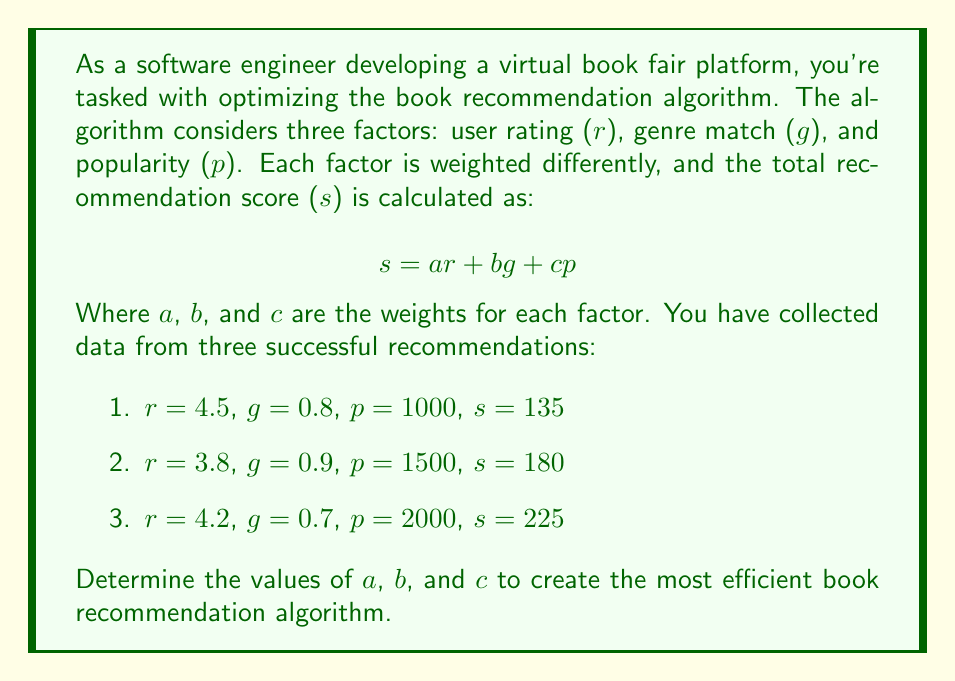Could you help me with this problem? To solve this problem, we need to set up a system of equations using the given data. Each recommendation provides us with an equation:

1. $4.5a + 0.8b + 1000c = 135$
2. $3.8a + 0.9b + 1500c = 180$
3. $4.2a + 0.7b + 2000c = 225$

Now we have a system of three equations with three unknowns. We can solve this using the elimination method:

Step 1: Multiply equation (1) by 2 and equation (2) by -1 to eliminate $b$:
$9a + 1.6b + 2000c = 270$
$-3.8a - 0.9b - 1500c = -180$
Adding these equations:
$5.2a + 0.7b + 500c = 90$ ... (4)

Step 2: Subtract equation (1) from equation (3) to eliminate $a$:
$-0.3a - 0.1b + 1000c = 90$ ... (5)

Step 3: Multiply equation (4) by 0.1 and equation (5) by 0.7:
$0.52a + 0.07b + 50c = 9$
$-0.21a - 0.07b + 700c = 63$
Adding these equations:
$0.31a + 750c = 72$ ... (6)

Step 4: Multiply equation (6) by 3.2258 to isolate $a$:
$a + 2419.35c = 232.26$ ... (7)

Step 5: Substitute this expression for $a$ into equation (1):
$4.5(232.26 - 2419.35c) + 0.8b + 1000c = 135$
$1045.17 - 10887.075c + 0.8b + 1000c = 135$
$0.8b - 9887.075c = -910.17$ ... (8)

Step 6: Solve equations (7) and (8) simultaneously:
From (7): $a = 232.26 - 2419.35c$
From (8): $b = (-910.17 + 9887.075c) / 0.8 = -1137.71 + 12358.84c$

Step 7: Substitute these expressions into equation (1):
$4.5(232.26 - 2419.35c) + 0.8(-1137.71 + 12358.84c) + 1000c = 135$
$1045.17 - 10887.075c - 910.168 + 9887.072c + 1000c = 135$
$135.002 - 0.003c = 135$
$-0.003c = -0.002$
$c = 0.667$

Step 8: Calculate $a$ and $b$ using the values found for $c$:
$a = 232.26 - 2419.35(0.667) = 232.26 - 1613.71 = 18.55$
$b = -1137.71 + 12358.84(0.667) = -1137.71 + 8243.35 = 7105.64$

Therefore, the values for $a$, $b$, and $c$ are approximately:
$a = 18.55$
$b = 7105.64$
$c = 0.667$
Answer: $a = 18.55$, $b = 7105.64$, $c = 0.667$ 